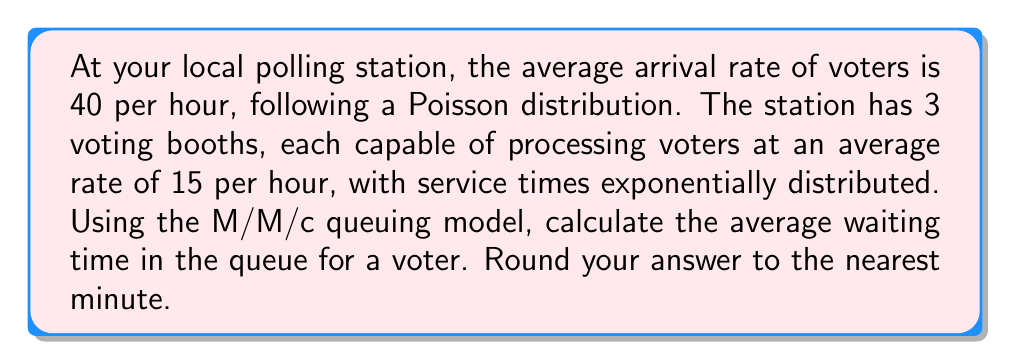What is the answer to this math problem? To solve this problem, we'll use the M/M/c queuing model, where:
M: Poisson arrival process
M: Exponential service times
c: Number of servers (voting booths)

Let's define our variables:
$\lambda$ = arrival rate = 40 voters/hour
$\mu$ = service rate per booth = 15 voters/hour
$c$ = number of booths = 3

Step 1: Calculate the utilization factor $\rho$
$$\rho = \frac{\lambda}{c\mu} = \frac{40}{3 \cdot 15} = \frac{40}{45} \approx 0.889$$

Step 2: Calculate $P_0$, the probability of an empty system
$$P_0 = \left[\sum_{n=0}^{c-1}\frac{(c\rho)^n}{n!} + \frac{(c\rho)^c}{c!(1-\rho)}\right]^{-1}$$

$$P_0 = \left[\frac{(3 \cdot 0.889)^0}{0!} + \frac{(3 \cdot 0.889)^1}{1!} + \frac{(3 \cdot 0.889)^2}{2!} + \frac{(3 \cdot 0.889)^3}{3!(1-0.889)}\right]^{-1}$$

$$P_0 \approx 0.0437$$

Step 3: Calculate $L_q$, the average number of voters in the queue
$$L_q = \frac{P_0(c\rho)^c\rho}{c!(1-\rho)^2}$$

$$L_q = \frac{0.0437 \cdot (3 \cdot 0.889)^3 \cdot 0.889}{3!(1-0.889)^2} \approx 5.3228$$

Step 4: Calculate $W_q$, the average waiting time in the queue
$$W_q = \frac{L_q}{\lambda}$$

$$W_q = \frac{5.3228}{40} \approx 0.1331 \text{ hours}$$

Convert to minutes:
$$0.1331 \text{ hours} \cdot 60 \text{ minutes/hour} \approx 7.986 \text{ minutes}$$

Rounding to the nearest minute, we get 8 minutes.
Answer: 8 minutes 